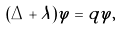Convert formula to latex. <formula><loc_0><loc_0><loc_500><loc_500>( \Delta + \lambda ) \varphi = q \varphi ,</formula> 